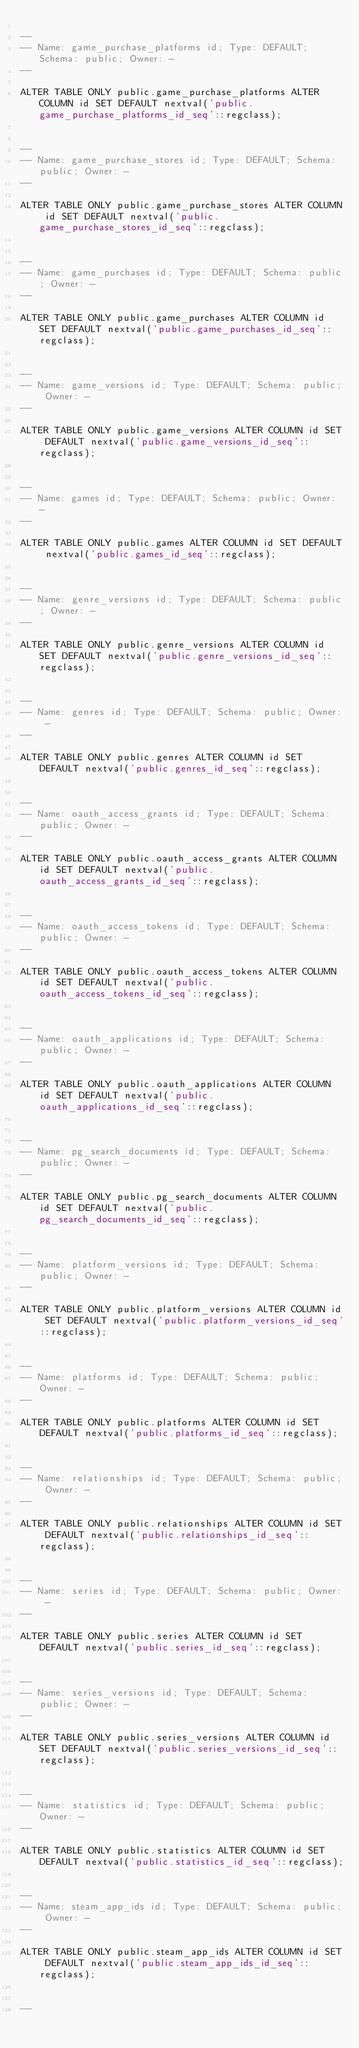Convert code to text. <code><loc_0><loc_0><loc_500><loc_500><_SQL_>
--
-- Name: game_purchase_platforms id; Type: DEFAULT; Schema: public; Owner: -
--

ALTER TABLE ONLY public.game_purchase_platforms ALTER COLUMN id SET DEFAULT nextval('public.game_purchase_platforms_id_seq'::regclass);


--
-- Name: game_purchase_stores id; Type: DEFAULT; Schema: public; Owner: -
--

ALTER TABLE ONLY public.game_purchase_stores ALTER COLUMN id SET DEFAULT nextval('public.game_purchase_stores_id_seq'::regclass);


--
-- Name: game_purchases id; Type: DEFAULT; Schema: public; Owner: -
--

ALTER TABLE ONLY public.game_purchases ALTER COLUMN id SET DEFAULT nextval('public.game_purchases_id_seq'::regclass);


--
-- Name: game_versions id; Type: DEFAULT; Schema: public; Owner: -
--

ALTER TABLE ONLY public.game_versions ALTER COLUMN id SET DEFAULT nextval('public.game_versions_id_seq'::regclass);


--
-- Name: games id; Type: DEFAULT; Schema: public; Owner: -
--

ALTER TABLE ONLY public.games ALTER COLUMN id SET DEFAULT nextval('public.games_id_seq'::regclass);


--
-- Name: genre_versions id; Type: DEFAULT; Schema: public; Owner: -
--

ALTER TABLE ONLY public.genre_versions ALTER COLUMN id SET DEFAULT nextval('public.genre_versions_id_seq'::regclass);


--
-- Name: genres id; Type: DEFAULT; Schema: public; Owner: -
--

ALTER TABLE ONLY public.genres ALTER COLUMN id SET DEFAULT nextval('public.genres_id_seq'::regclass);


--
-- Name: oauth_access_grants id; Type: DEFAULT; Schema: public; Owner: -
--

ALTER TABLE ONLY public.oauth_access_grants ALTER COLUMN id SET DEFAULT nextval('public.oauth_access_grants_id_seq'::regclass);


--
-- Name: oauth_access_tokens id; Type: DEFAULT; Schema: public; Owner: -
--

ALTER TABLE ONLY public.oauth_access_tokens ALTER COLUMN id SET DEFAULT nextval('public.oauth_access_tokens_id_seq'::regclass);


--
-- Name: oauth_applications id; Type: DEFAULT; Schema: public; Owner: -
--

ALTER TABLE ONLY public.oauth_applications ALTER COLUMN id SET DEFAULT nextval('public.oauth_applications_id_seq'::regclass);


--
-- Name: pg_search_documents id; Type: DEFAULT; Schema: public; Owner: -
--

ALTER TABLE ONLY public.pg_search_documents ALTER COLUMN id SET DEFAULT nextval('public.pg_search_documents_id_seq'::regclass);


--
-- Name: platform_versions id; Type: DEFAULT; Schema: public; Owner: -
--

ALTER TABLE ONLY public.platform_versions ALTER COLUMN id SET DEFAULT nextval('public.platform_versions_id_seq'::regclass);


--
-- Name: platforms id; Type: DEFAULT; Schema: public; Owner: -
--

ALTER TABLE ONLY public.platforms ALTER COLUMN id SET DEFAULT nextval('public.platforms_id_seq'::regclass);


--
-- Name: relationships id; Type: DEFAULT; Schema: public; Owner: -
--

ALTER TABLE ONLY public.relationships ALTER COLUMN id SET DEFAULT nextval('public.relationships_id_seq'::regclass);


--
-- Name: series id; Type: DEFAULT; Schema: public; Owner: -
--

ALTER TABLE ONLY public.series ALTER COLUMN id SET DEFAULT nextval('public.series_id_seq'::regclass);


--
-- Name: series_versions id; Type: DEFAULT; Schema: public; Owner: -
--

ALTER TABLE ONLY public.series_versions ALTER COLUMN id SET DEFAULT nextval('public.series_versions_id_seq'::regclass);


--
-- Name: statistics id; Type: DEFAULT; Schema: public; Owner: -
--

ALTER TABLE ONLY public.statistics ALTER COLUMN id SET DEFAULT nextval('public.statistics_id_seq'::regclass);


--
-- Name: steam_app_ids id; Type: DEFAULT; Schema: public; Owner: -
--

ALTER TABLE ONLY public.steam_app_ids ALTER COLUMN id SET DEFAULT nextval('public.steam_app_ids_id_seq'::regclass);


--</code> 